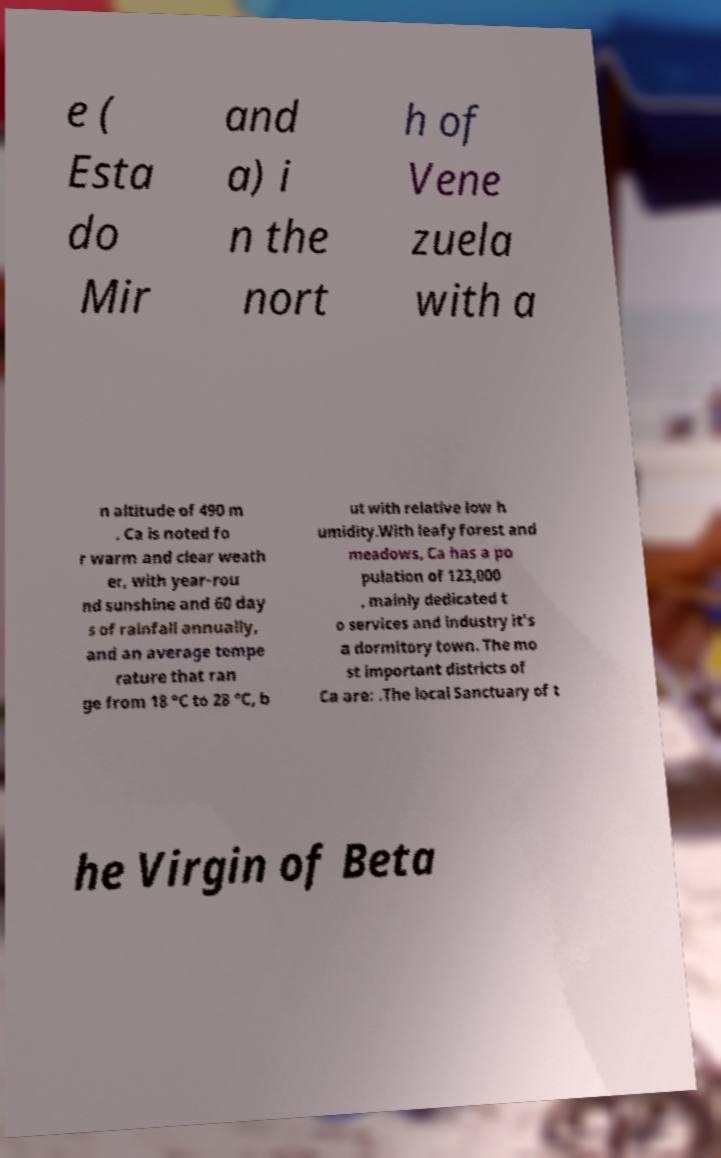Please read and relay the text visible in this image. What does it say? e ( Esta do Mir and a) i n the nort h of Vene zuela with a n altitude of 490 m . Ca is noted fo r warm and clear weath er, with year-rou nd sunshine and 60 day s of rainfall annually, and an average tempe rature that ran ge from 18 °C to 28 °C, b ut with relative low h umidity.With leafy forest and meadows, Ca has a po pulation of 123,000 , mainly dedicated t o services and industry it's a dormitory town. The mo st important districts of Ca are: .The local Sanctuary of t he Virgin of Beta 